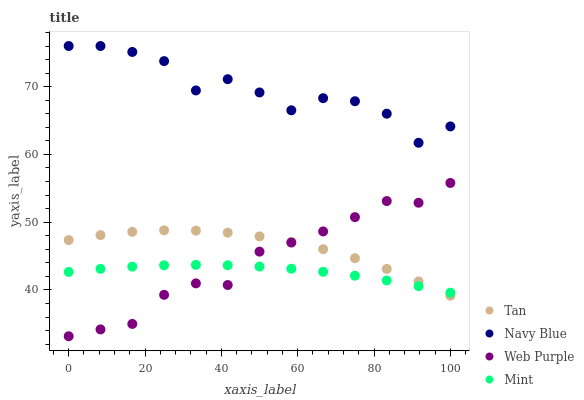Does Mint have the minimum area under the curve?
Answer yes or no. Yes. Does Navy Blue have the maximum area under the curve?
Answer yes or no. Yes. Does Tan have the minimum area under the curve?
Answer yes or no. No. Does Tan have the maximum area under the curve?
Answer yes or no. No. Is Mint the smoothest?
Answer yes or no. Yes. Is Navy Blue the roughest?
Answer yes or no. Yes. Is Tan the smoothest?
Answer yes or no. No. Is Tan the roughest?
Answer yes or no. No. Does Web Purple have the lowest value?
Answer yes or no. Yes. Does Tan have the lowest value?
Answer yes or no. No. Does Navy Blue have the highest value?
Answer yes or no. Yes. Does Tan have the highest value?
Answer yes or no. No. Is Web Purple less than Navy Blue?
Answer yes or no. Yes. Is Navy Blue greater than Mint?
Answer yes or no. Yes. Does Tan intersect Mint?
Answer yes or no. Yes. Is Tan less than Mint?
Answer yes or no. No. Is Tan greater than Mint?
Answer yes or no. No. Does Web Purple intersect Navy Blue?
Answer yes or no. No. 